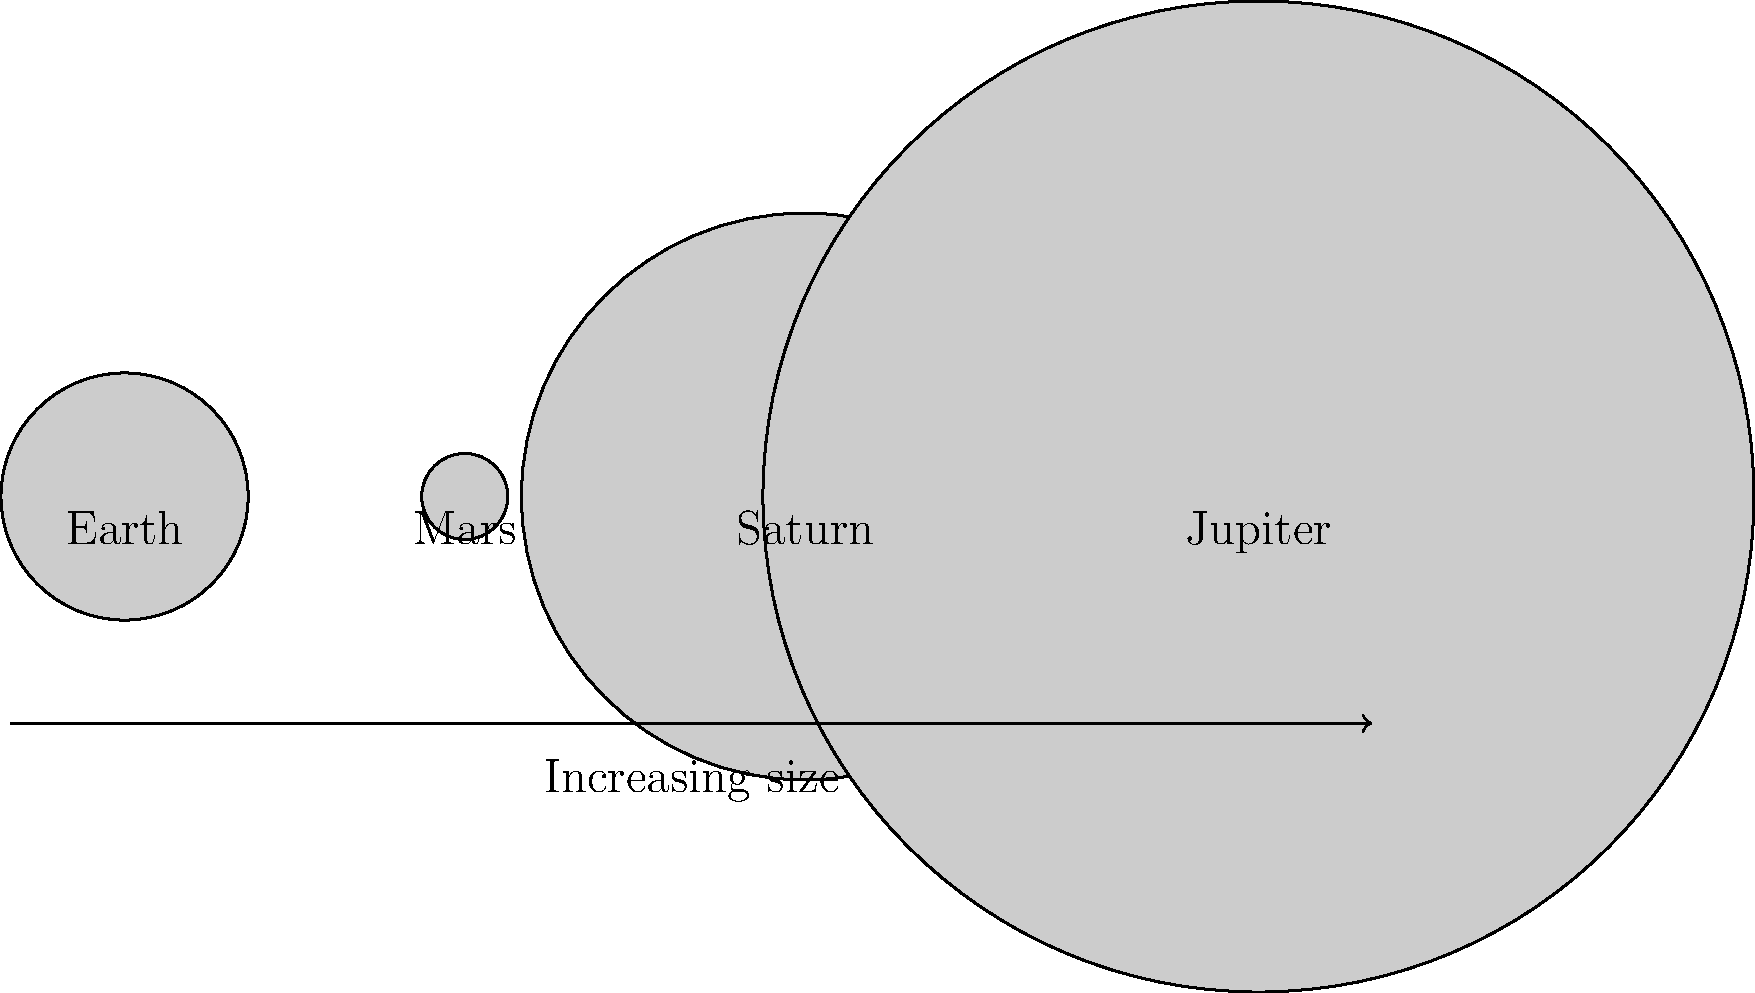In the diagram above, four planets from our solar system are represented by scaled circles. If you were to arrange these planets in order from smallest to largest, which sequence would be correct? To answer this question, we need to compare the sizes of the circles representing each planet:

1. First, let's identify each planet:
   - The leftmost circle is labeled "Earth"
   - The second circle from the left is labeled "Mars"
   - The third circle from the left is labeled "Saturn"
   - The rightmost and largest circle is labeled "Jupiter"

2. Now, let's compare their sizes visually:
   - Mars appears to be the smallest circle
   - Earth is slightly larger than Mars
   - Saturn is significantly larger than Earth
   - Jupiter is the largest circle in the diagram

3. The arrow at the bottom of the diagram confirms that the size increases from left to right, with the exception of Earth being slightly larger than Mars.

4. Therefore, the correct order from smallest to largest is:
   Mars < Earth < Saturn < Jupiter

This sequence aligns with the actual relative sizes of these planets in our solar system. Mars is indeed the smallest of these four, while Jupiter is the largest planet in our entire solar system.
Answer: Mars, Earth, Saturn, Jupiter 